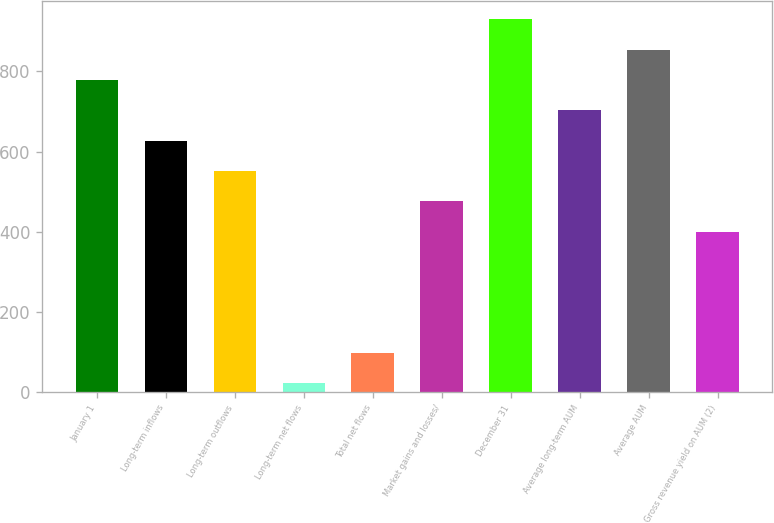Convert chart to OTSL. <chart><loc_0><loc_0><loc_500><loc_500><bar_chart><fcel>January 1<fcel>Long-term inflows<fcel>Long-term outflows<fcel>Long-term net flows<fcel>Total net flows<fcel>Market gains and losses/<fcel>December 31<fcel>Average long-term AUM<fcel>Average AUM<fcel>Gross revenue yield on AUM (2)<nl><fcel>778.7<fcel>627.3<fcel>551.6<fcel>21.7<fcel>97.4<fcel>475.9<fcel>930.1<fcel>703<fcel>854.4<fcel>400.2<nl></chart> 